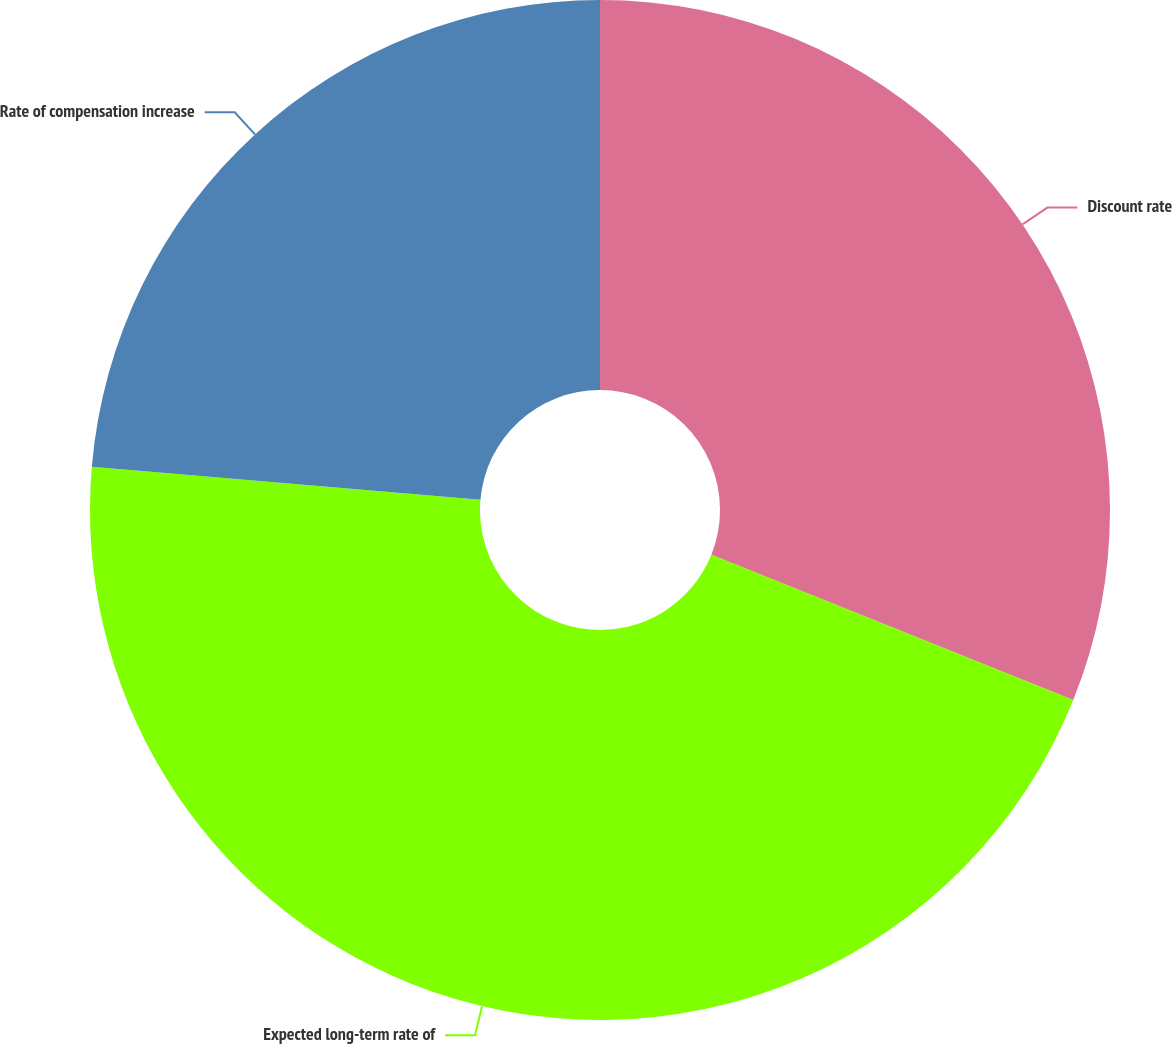<chart> <loc_0><loc_0><loc_500><loc_500><pie_chart><fcel>Discount rate<fcel>Expected long-term rate of<fcel>Rate of compensation increase<nl><fcel>31.08%<fcel>45.27%<fcel>23.65%<nl></chart> 